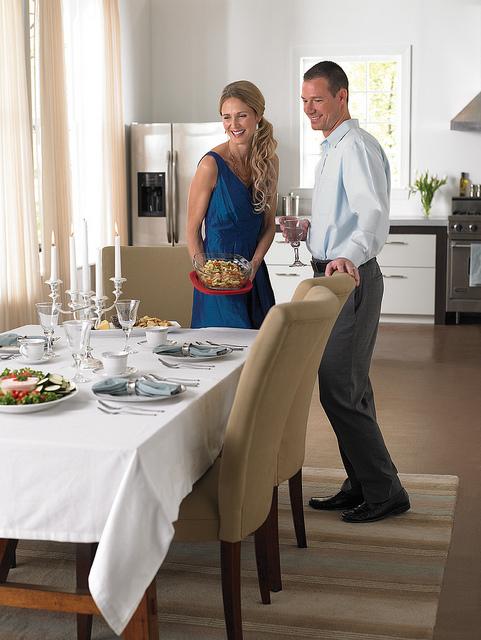Are they ready to have dinner?
Be succinct. Yes. Are they dressed up?
Answer briefly. Yes. How many candles are in the picture?
Be succinct. 5. 